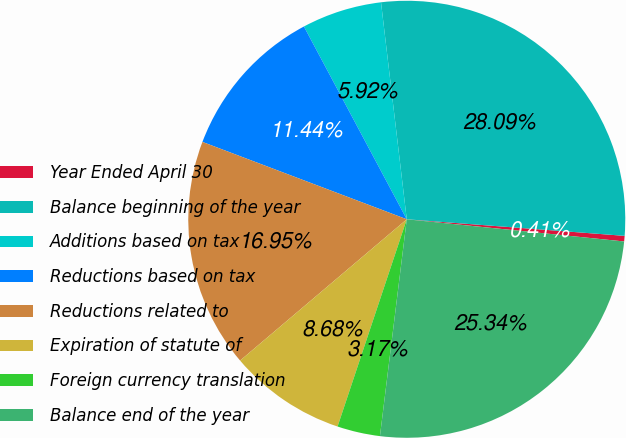Convert chart to OTSL. <chart><loc_0><loc_0><loc_500><loc_500><pie_chart><fcel>Year Ended April 30<fcel>Balance beginning of the year<fcel>Additions based on tax<fcel>Reductions based on tax<fcel>Reductions related to<fcel>Expiration of statute of<fcel>Foreign currency translation<fcel>Balance end of the year<nl><fcel>0.41%<fcel>28.09%<fcel>5.92%<fcel>11.44%<fcel>16.95%<fcel>8.68%<fcel>3.17%<fcel>25.34%<nl></chart> 